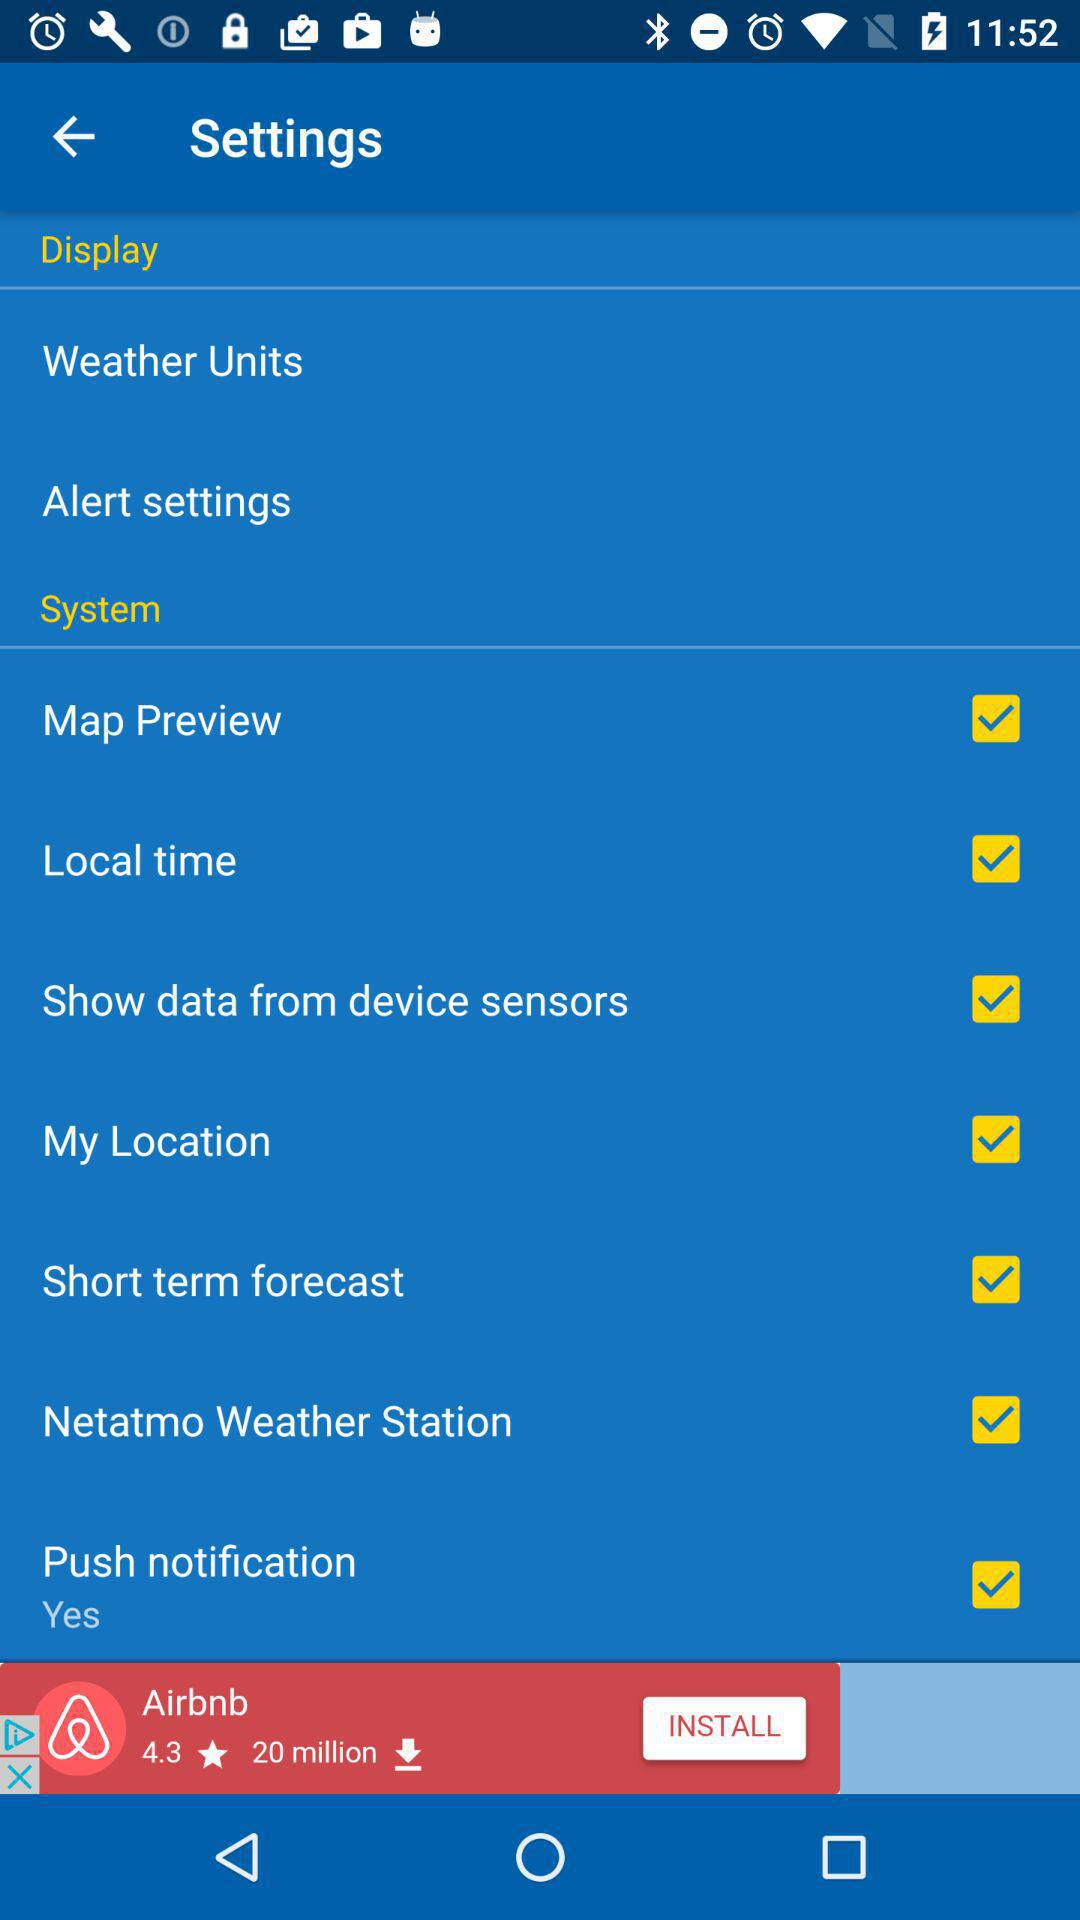Which checkbox is checked? The checkboxes that are checked are "Map Preview", "Local time", "Show data from device sensors", "My Location", "Short term forecast", "Netatmo Weather Station" and "Push notification". 